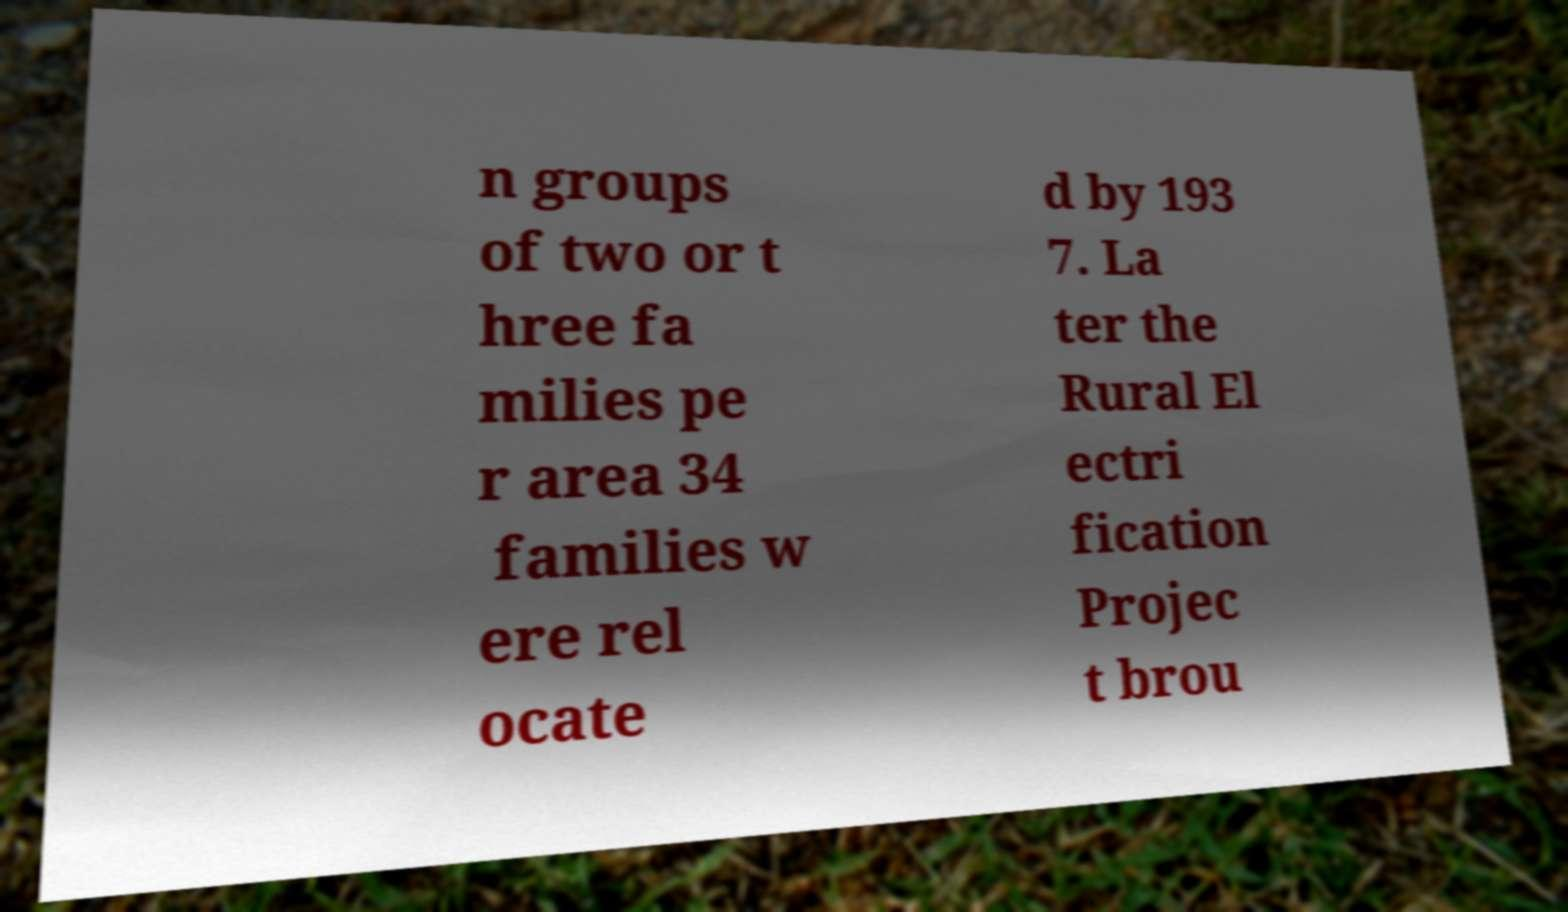Please identify and transcribe the text found in this image. n groups of two or t hree fa milies pe r area 34 families w ere rel ocate d by 193 7. La ter the Rural El ectri fication Projec t brou 